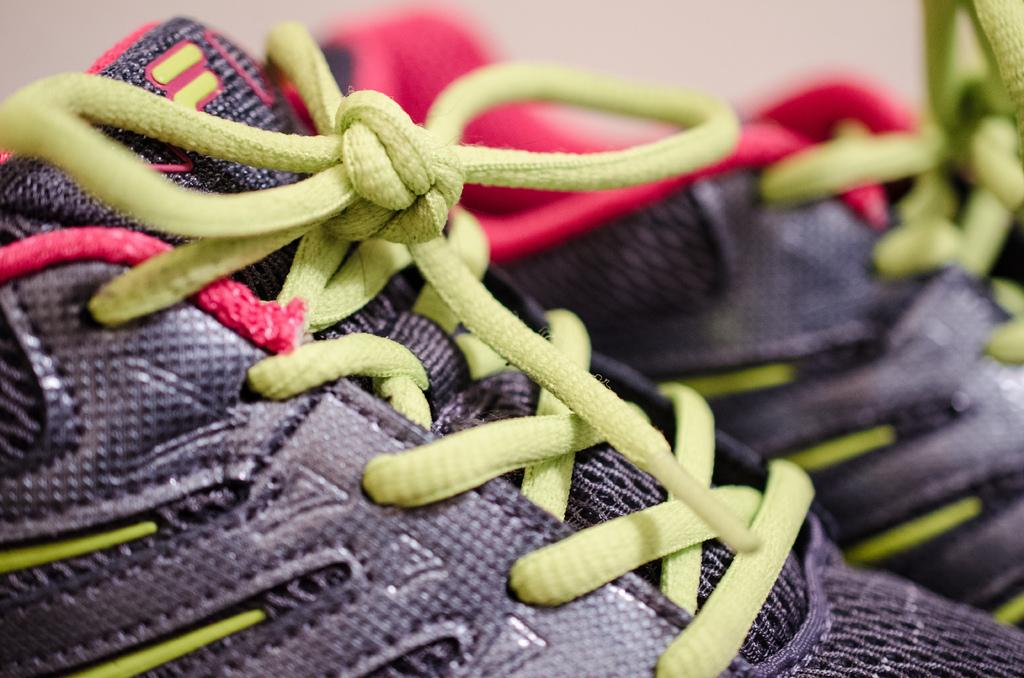What type of footwear is visible in the image? There are shoes in the image. What part of the shoes is visible in the image? There are shoelaces in the image. What type of flower is growing in the wilderness near the doctor in the image? There is no flower, wilderness, or doctor present in the image; it only features shoes and shoelaces. 